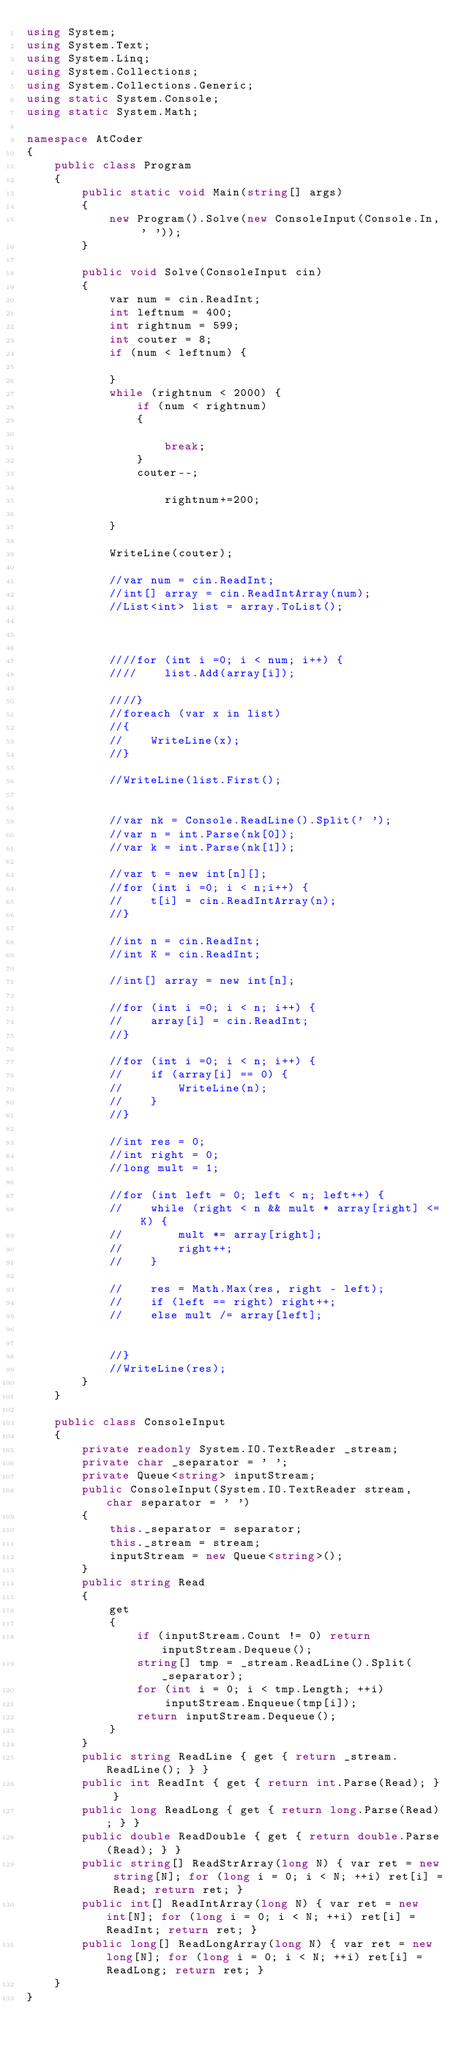Convert code to text. <code><loc_0><loc_0><loc_500><loc_500><_C#_>using System;
using System.Text;
using System.Linq;
using System.Collections;
using System.Collections.Generic;
using static System.Console;
using static System.Math;

namespace AtCoder
{
    public class Program
    {
        public static void Main(string[] args)
        {
            new Program().Solve(new ConsoleInput(Console.In, ' '));
        }

        public void Solve(ConsoleInput cin)
        {
            var num = cin.ReadInt;
            int leftnum = 400;
            int rightnum = 599;
            int couter = 8;
            if (num < leftnum) {

            }
            while (rightnum < 2000) {
                if (num < rightnum)
                {
        
                    break;
                }
                couter--;

                    rightnum+=200;

            }

            WriteLine(couter);

            //var num = cin.ReadInt;
            //int[] array = cin.ReadIntArray(num);
            //List<int> list = array.ToList();



            ////for (int i =0; i < num; i++) {
            ////    list.Add(array[i]);

            ////}
            //foreach (var x in list)
            //{
            //    WriteLine(x);
            //}

            //WriteLine(list.First();


            //var nk = Console.ReadLine().Split(' ');
            //var n = int.Parse(nk[0]);
            //var k = int.Parse(nk[1]);

            //var t = new int[n][];
            //for (int i =0; i < n;i++) {
            //    t[i] = cin.ReadIntArray(n);
            //}

            //int n = cin.ReadInt;
            //int K = cin.ReadInt;

            //int[] array = new int[n];

            //for (int i =0; i < n; i++) {
            //    array[i] = cin.ReadInt;
            //}

            //for (int i =0; i < n; i++) {
            //    if (array[i] == 0) {
            //        WriteLine(n);
            //    }
            //}

            //int res = 0;
            //int right = 0;
            //long mult = 1;

            //for (int left = 0; left < n; left++) {
            //    while (right < n && mult * array[right] <= K) {
            //        mult *= array[right];
            //        right++;
            //    }

            //    res = Math.Max(res, right - left);
            //    if (left == right) right++;
            //    else mult /= array[left];


            //}
            //WriteLine(res);
        }
    }

    public class ConsoleInput
    {
        private readonly System.IO.TextReader _stream;
        private char _separator = ' ';
        private Queue<string> inputStream;
        public ConsoleInput(System.IO.TextReader stream, char separator = ' ')
        {
            this._separator = separator;
            this._stream = stream;
            inputStream = new Queue<string>();
        }
        public string Read
        {
            get
            {
                if (inputStream.Count != 0) return inputStream.Dequeue();
                string[] tmp = _stream.ReadLine().Split(_separator);
                for (int i = 0; i < tmp.Length; ++i)
                    inputStream.Enqueue(tmp[i]);
                return inputStream.Dequeue();
            }
        }
        public string ReadLine { get { return _stream.ReadLine(); } }
        public int ReadInt { get { return int.Parse(Read); } }
        public long ReadLong { get { return long.Parse(Read); } }
        public double ReadDouble { get { return double.Parse(Read); } }
        public string[] ReadStrArray(long N) { var ret = new string[N]; for (long i = 0; i < N; ++i) ret[i] = Read; return ret; }
        public int[] ReadIntArray(long N) { var ret = new int[N]; for (long i = 0; i < N; ++i) ret[i] = ReadInt; return ret; }
        public long[] ReadLongArray(long N) { var ret = new long[N]; for (long i = 0; i < N; ++i) ret[i] = ReadLong; return ret; }
    }
}</code> 